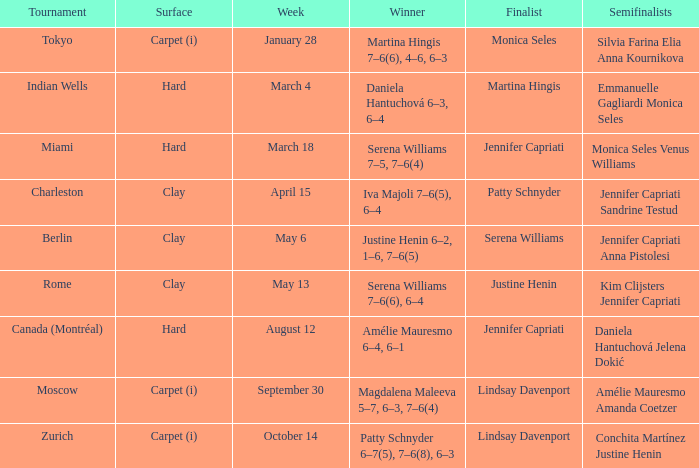In what contest was monica seles a finalist? Tokyo. 